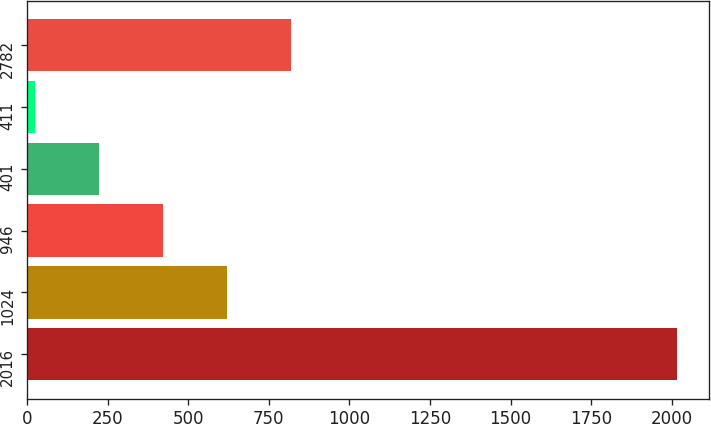Convert chart. <chart><loc_0><loc_0><loc_500><loc_500><bar_chart><fcel>2016<fcel>1024<fcel>946<fcel>401<fcel>411<fcel>2782<nl><fcel>2015<fcel>621.09<fcel>421.96<fcel>222.83<fcel>23.7<fcel>820.22<nl></chart> 